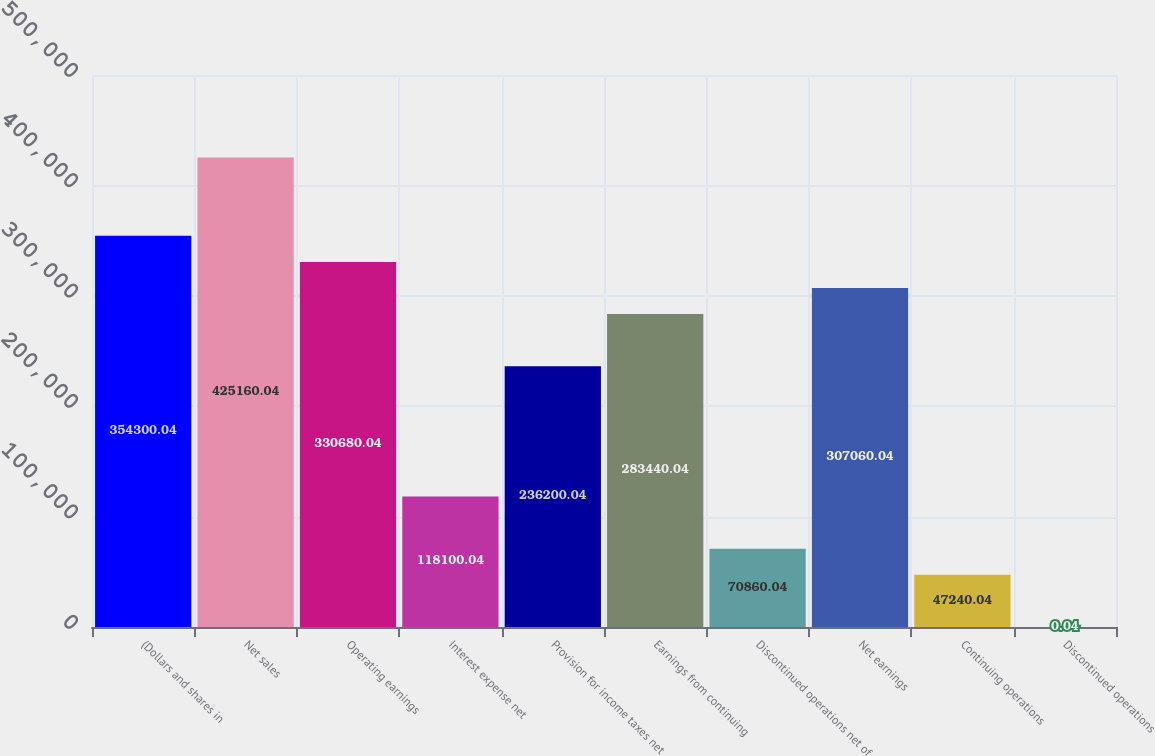Convert chart. <chart><loc_0><loc_0><loc_500><loc_500><bar_chart><fcel>(Dollars and shares in<fcel>Net sales<fcel>Operating earnings<fcel>Interest expense net<fcel>Provision for income taxes net<fcel>Earnings from continuing<fcel>Discontinued operations net of<fcel>Net earnings<fcel>Continuing operations<fcel>Discontinued operations<nl><fcel>354300<fcel>425160<fcel>330680<fcel>118100<fcel>236200<fcel>283440<fcel>70860<fcel>307060<fcel>47240<fcel>0.04<nl></chart> 